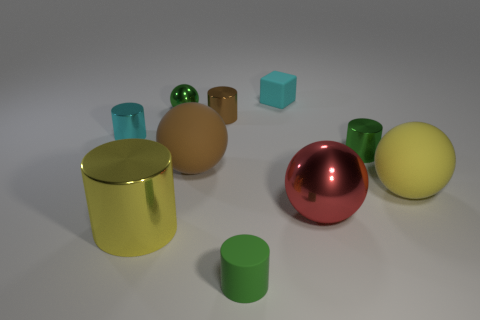Subtract 1 balls. How many balls are left? 3 Subtract all brown cylinders. How many cylinders are left? 4 Subtract all green blocks. Subtract all yellow balls. How many blocks are left? 1 Subtract all spheres. How many objects are left? 6 Add 2 tiny green cylinders. How many tiny green cylinders are left? 4 Add 5 tiny cyan shiny cylinders. How many tiny cyan shiny cylinders exist? 6 Subtract 1 brown cylinders. How many objects are left? 9 Subtract all tiny cylinders. Subtract all tiny metal balls. How many objects are left? 5 